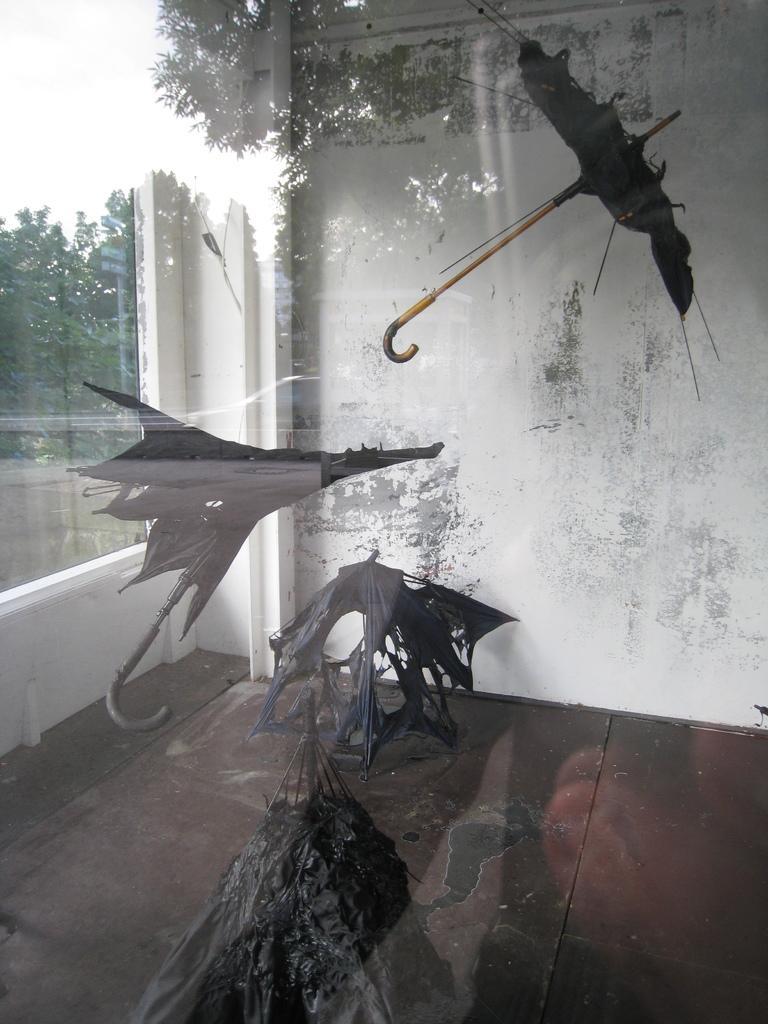How would you summarize this image in a sentence or two? In this image we can see there is a view from the glass where we can see there is a wall and some broken umbrella and some trees outside the window. 